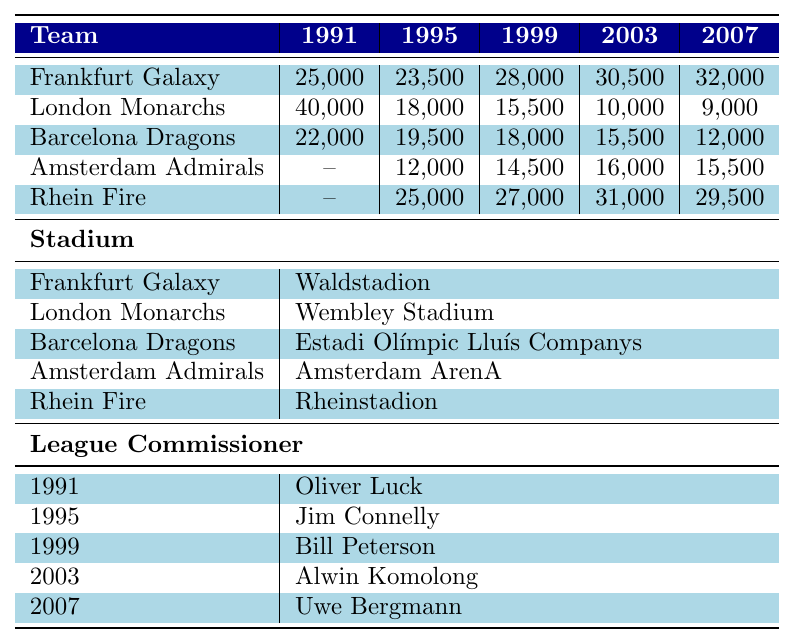What was the highest attendance in 1991? The table shows the attendance figures for 1991: Frankfurt Galaxy had 25,000, London Monarchs had 40,000, Barcelona Dragons had 22,000, Amsterdam Admirals have no data, and Rhein Fire has no data. The highest value is 40,000 from the London Monarchs.
Answer: 40,000 Which team had the lowest attendance in 2007? The attendance figures for 2007 are: Frankfurt Galaxy with 32,000, London Monarchs with 9,000, Barcelona Dragons with 12,000, Amsterdam Admirals with 15,500, and Rhein Fire with 29,500. The lowest is 9,000 from the London Monarchs.
Answer: 9,000 What was the average attendance of the Barcelona Dragons from 1991 to 2007? The attendance figures for Barcelona Dragons are: 22,000, 19,500, 18,000, 15,500, and 12,000. To calculate the average, sum these values: 22,000 + 19,500 + 18,000 + 15,500 + 12,000 = 87,000. Dividing by 5 gives an average of 17,400.
Answer: 17,400 Did the attendance for the London Monarchs increase from 1991 to 2007? The attendance figures for London Monarchs are: 40,000 in 1991 and 9,000 in 2007. Since 9,000 is less than 40,000, the attendance did not increase.
Answer: No Which team had the highest average attendance over the years from 1991 to 2007? To find the highest average attendance: Frankfurt Galaxy: (25000 + 23500 + 28000 + 30500 + 32000)/5 = 25800; London Monarchs: (40000 + 18000 + 15500 + 10000 + 9000)/5 = 17820; Barcelona Dragons: (22000 + 19500 + 18000 + 15500 + 12000)/5 = 17400; Amsterdam Admirals: (12000 + 14500 + 16000 + 15500)/4 = 14500; Rhein Fire: (25000 + 27000 + 31000 + 29500)/4 = 27625. The highest is Rhein Fire with 27,625.
Answer: Rhein Fire Which stadium was used for the London Monarchs? The stadium associated with London Monarchs, as per the table, is Wembley Stadium.
Answer: Wembley Stadium What was the difference in attendance for Frankfurt Galaxy between 1991 and 2007? The attendance for Frankfurt Galaxy in 1991 was 25,000 and in 2007 it was 32,000. The difference is 32,000 - 25,000 = 7,000.
Answer: 7,000 Is it true that Amsterdam Admirals had a consistent increase in attendance from 1995 to 2007? The attendance figures for Amsterdam Admirals from 1995 to 2007 are: 12,000, 14,500, 16,000, and 15,500. The data indicates a decrease from 16,000 to 15,500, indicating not a consistent increase.
Answer: No What are the total attendance figures for the Rhein Fire from 1995 to 2007? The attendance figures for Rhein Fire are: 25,000 in 1995, 27,000 in 1999, 31,000 in 2003, and 29,500 in 2007. Summing these gives: 25,000 + 27,000 + 31,000 + 29,500 = 112,500.
Answer: 112,500 Which league commissioner oversaw the NFL Europe in 1999? According to the table, the league commissioner for 1999 was Bill Peterson.
Answer: Bill Peterson What city hosted the Frankfurt Galaxy games? The city that hosted the Frankfurt Galaxy games is Frankfurt.
Answer: Frankfurt 